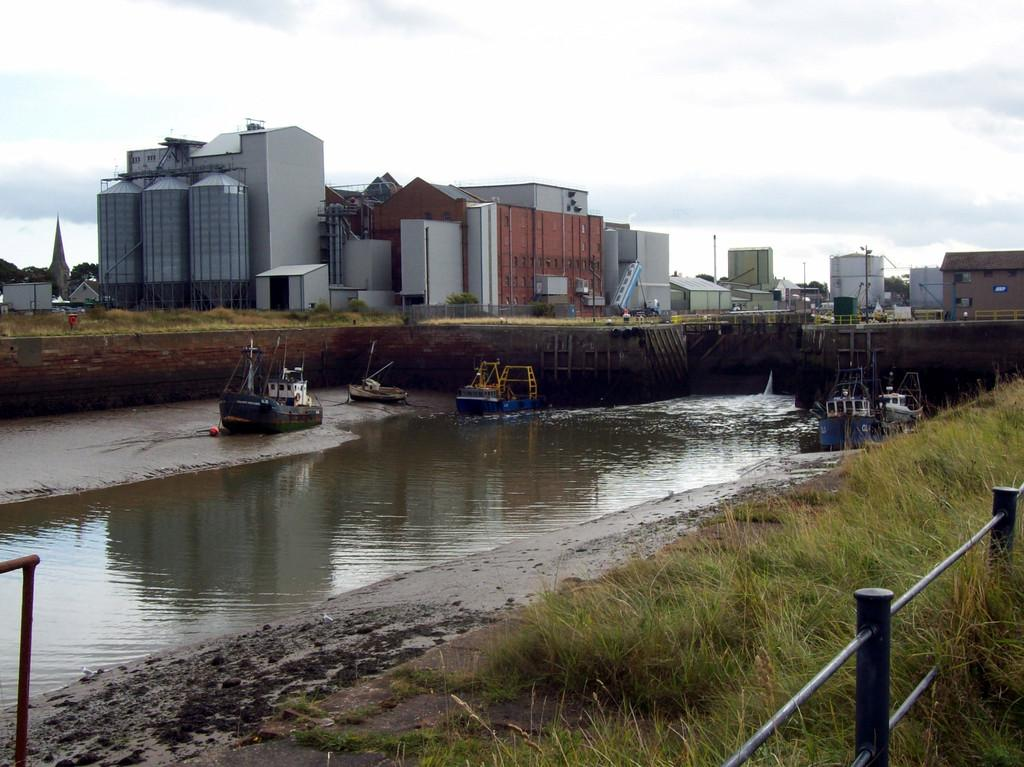What type of environment is depicted in the image? The image shows a water environment with grass, boats, buildings, and the sky visible. What type of vegetation can be seen in the image? There is grass in the image. What structures are present in the image? There are boats and buildings in the image. What is visible in the sky in the image? The sky is visible in the image. What caption is written on the edge of the image? There is no caption present on the edge of the image. What time of day is depicted in the image? The time of day cannot be determined from the image, as there is no specific indication of day or night. 